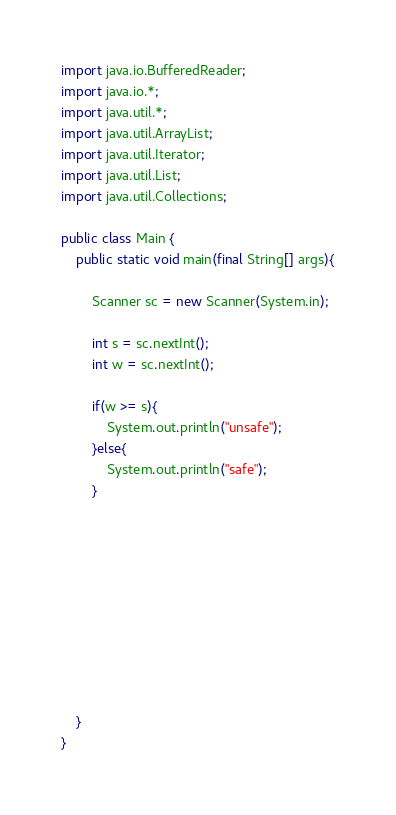Convert code to text. <code><loc_0><loc_0><loc_500><loc_500><_Java_>import java.io.BufferedReader;
import java.io.*;
import java.util.*;
import java.util.ArrayList;
import java.util.Iterator;
import java.util.List;
import java.util.Collections;

public class Main {
	public static void main(final String[] args){
    
        Scanner sc = new Scanner(System.in);

        int s = sc.nextInt();
        int w = sc.nextInt();

        if(w >= s){
            System.out.println("unsafe");
        }else{
            System.out.println("safe");
        }
        
        

        






    }
}</code> 